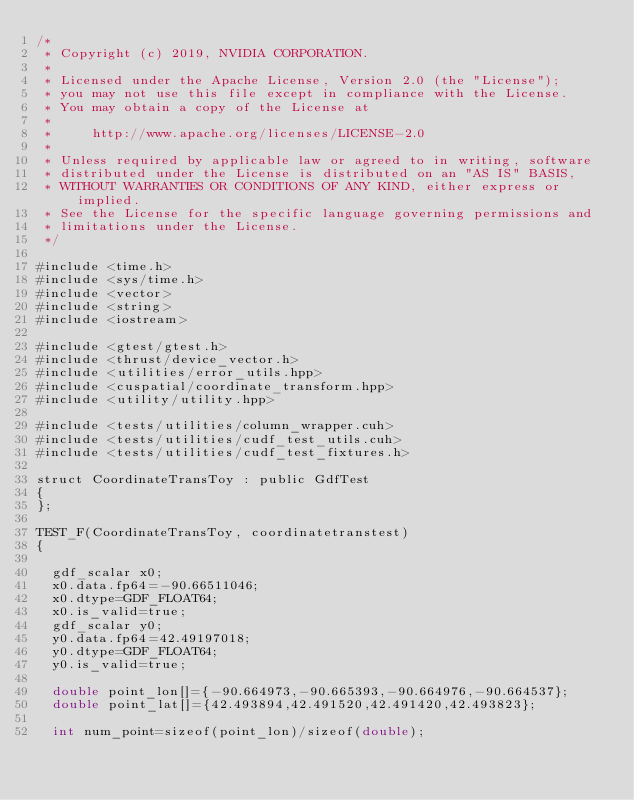Convert code to text. <code><loc_0><loc_0><loc_500><loc_500><_Cuda_>/*
 * Copyright (c) 2019, NVIDIA CORPORATION.
 *
 * Licensed under the Apache License, Version 2.0 (the "License");
 * you may not use this file except in compliance with the License.
 * You may obtain a copy of the License at
 *
 *     http://www.apache.org/licenses/LICENSE-2.0
 *
 * Unless required by applicable law or agreed to in writing, software
 * distributed under the License is distributed on an "AS IS" BASIS,
 * WITHOUT WARRANTIES OR CONDITIONS OF ANY KIND, either express or implied.
 * See the License for the specific language governing permissions and
 * limitations under the License.
 */

#include <time.h>
#include <sys/time.h>
#include <vector>
#include <string>
#include <iostream>

#include <gtest/gtest.h>
#include <thrust/device_vector.h>
#include <utilities/error_utils.hpp>
#include <cuspatial/coordinate_transform.hpp>
#include <utility/utility.hpp>

#include <tests/utilities/column_wrapper.cuh>
#include <tests/utilities/cudf_test_utils.cuh>
#include <tests/utilities/cudf_test_fixtures.h>

struct CoordinateTransToy : public GdfTest 
{
};   
   
TEST_F(CoordinateTransToy, coordinatetranstest)
{

  gdf_scalar x0; 
  x0.data.fp64=-90.66511046;
  x0.dtype=GDF_FLOAT64;
  x0.is_valid=true;
  gdf_scalar y0;
  y0.data.fp64=42.49197018;
  y0.dtype=GDF_FLOAT64;
  y0.is_valid=true;
  
  double point_lon[]={-90.664973,-90.665393,-90.664976,-90.664537};
  double point_lat[]={42.493894,42.491520,42.491420,42.493823};
  
  int num_point=sizeof(point_lon)/sizeof(double);</code> 